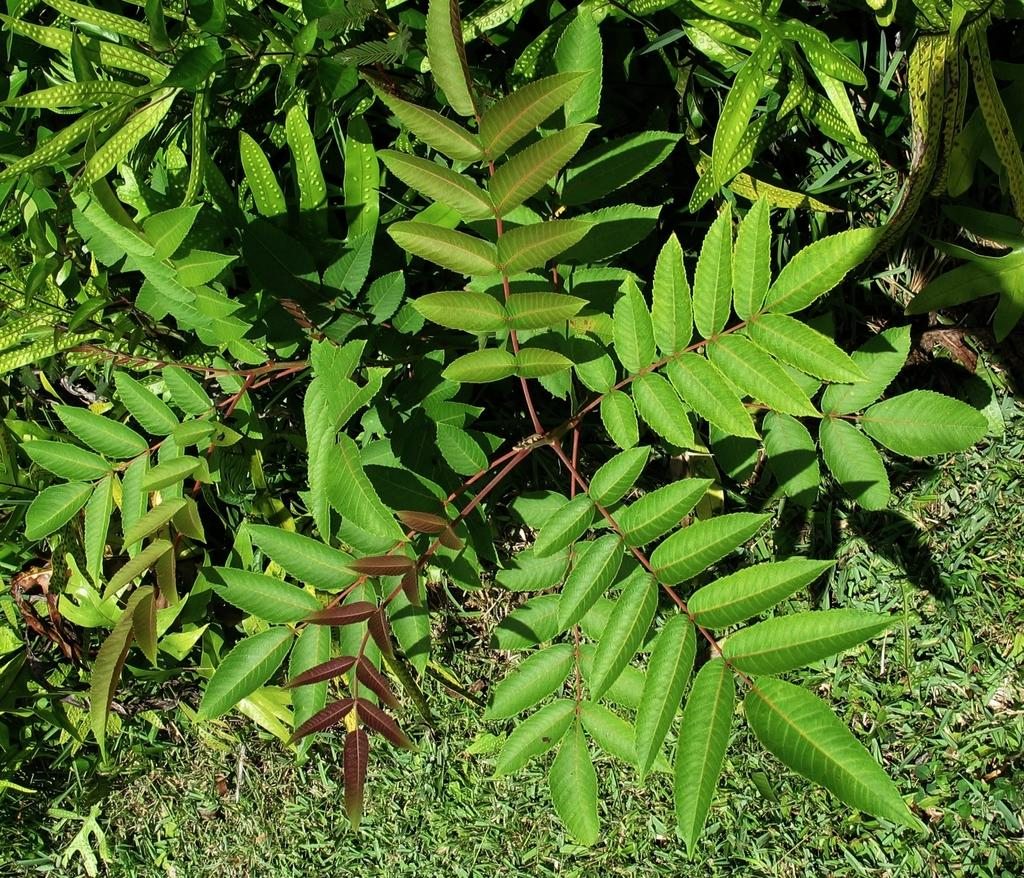What type of living organisms can be seen in the image? Plants can be seen in the image. Where are the plants located? The plants are on a greenery ground. What type of toothbrush is visible in the image? There is no toothbrush present in the image. Can you hear any thunder in the image? There is no sound or indication of thunder in the image. 